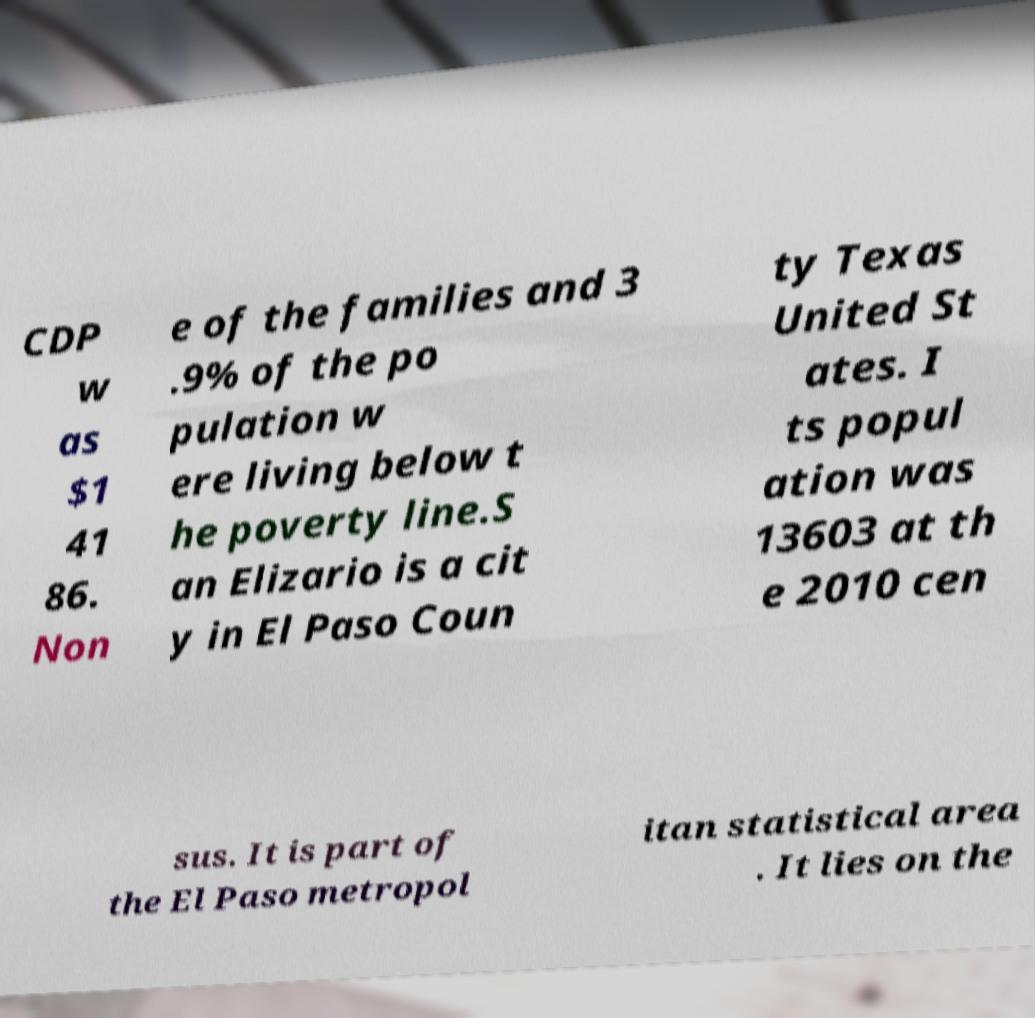Could you assist in decoding the text presented in this image and type it out clearly? CDP w as $1 41 86. Non e of the families and 3 .9% of the po pulation w ere living below t he poverty line.S an Elizario is a cit y in El Paso Coun ty Texas United St ates. I ts popul ation was 13603 at th e 2010 cen sus. It is part of the El Paso metropol itan statistical area . It lies on the 